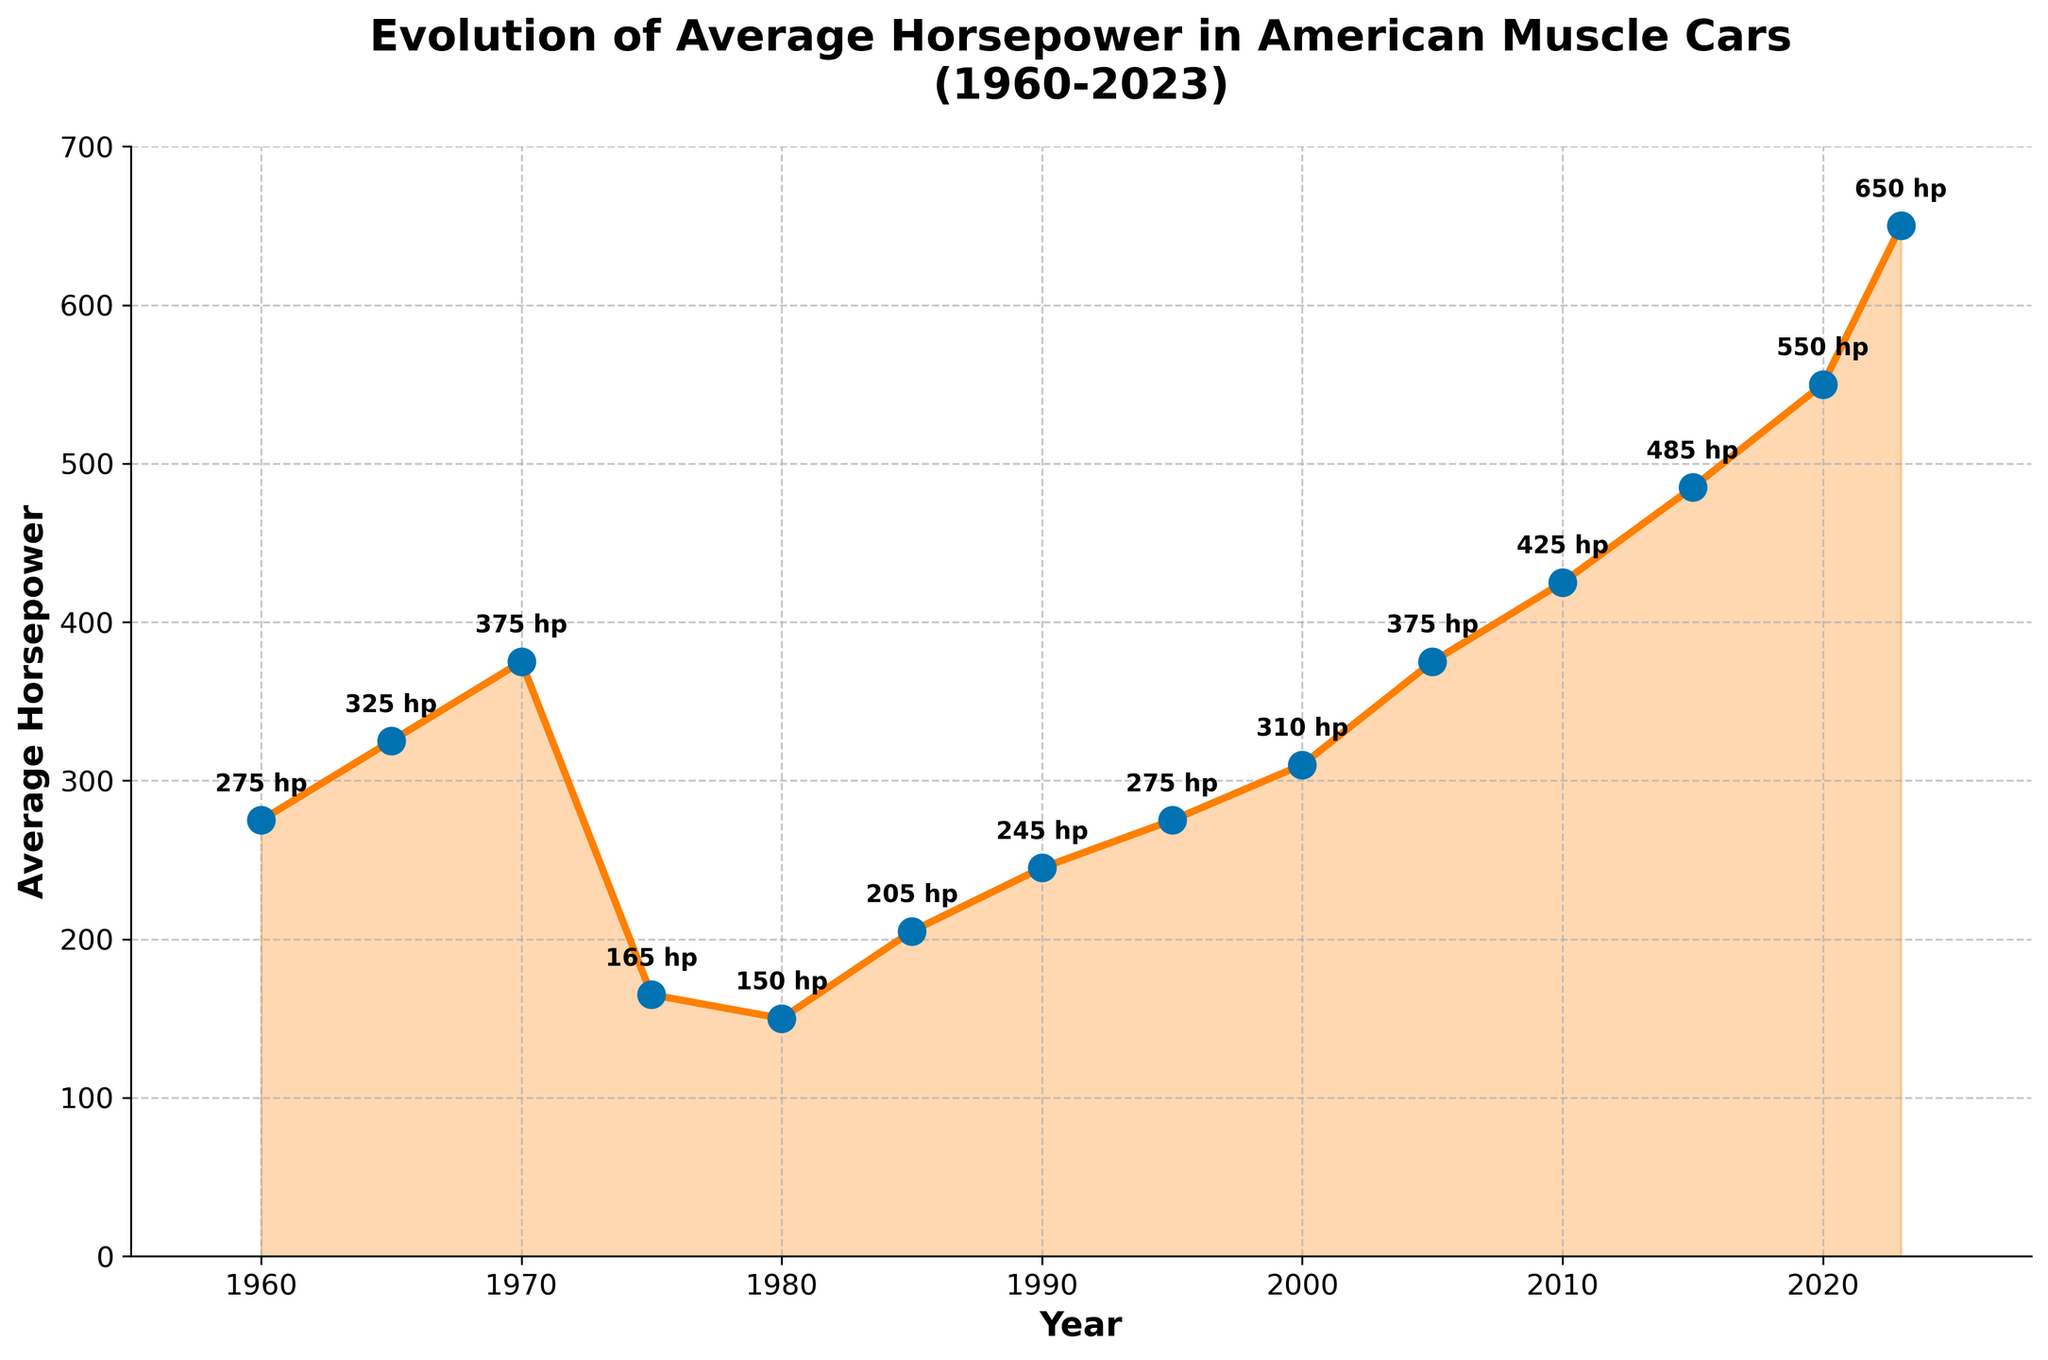What is the average horsepower in 2023? Looking at the figure, find the data point for the year 2023. The horsepower value is directly labeled as 650 hp.
Answer: 650 hp What is the largest increase in horsepower within any 5-year period? Identify the two years with the largest difference in horsepower values within a 5-year span. From 2015 to 2020, horsepower increases from 485 hp to 550 hp, an increase of 65 hp.
Answer: 65 hp How did the horsepower change between 1970 and 1975? Locate the points for 1970 and 1975 on the figure. In 1970, the horsepower is 375 hp, and in 1975, it is 165 hp. The difference is 375 - 165 = 210 hp.
Answer: Decreased by 210 hp How many times did the average horsepower reach 375 hp? Checking the figure, we see that the horsepower in 1970 and 2005 are both 375 hp. This happens twice.
Answer: Twice What is the trend in horsepower from 1980 to 2000? Look at the points for 1980 (150 hp) and 2000 (310 hp). The horsepower increases over this period.
Answer: Increasing What is the difference in average horsepower between 1985 and 1995? The figure shows horsepower values of 205 hp in 1985 and 275 hp in 1995. The difference is 275 - 205 = 70 hp.
Answer: 70 hp Which year experienced the steepest increase in horsepower post-2000? Identify the period with the largest upward slope after 2000. From 2015 to 2020, it increases from 485 hp to 550 hp, a rise of 65 hp. Post-2020, the rise is steeper from 550 hp to 650 hp (100 hp).
Answer: 2020-2023 In which two consecutive periods did horsepower decrease the most? Find the consecutive periods with the largest downward change in the plot. From 1970 to 1975 (375 hp to 165 hp) is the largest decrease at 210 hp.
Answer: 1970-1975 What is the period of lowest horsepower, and when did it start rising again? The lowest point on the graph is at 1980 (150 hp). It starts rising from 150 hp in 1980 to 205 hp in 1985.
Answer: 1980, starts rising in 1985 What is the overall trend in the evolution of average horsepower in American muscle cars from 1960 to present? Observing the entire figure, the overall trend from 1960 (275 hp) to 2023 (650 hp) shows a significant increase in average horsepower, despite some fluctuations.
Answer: Increasing trend 